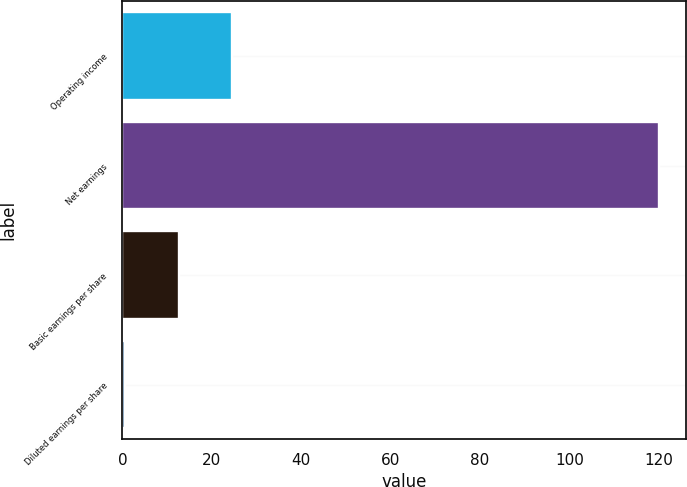Convert chart to OTSL. <chart><loc_0><loc_0><loc_500><loc_500><bar_chart><fcel>Operating income<fcel>Net earnings<fcel>Basic earnings per share<fcel>Diluted earnings per share<nl><fcel>24.54<fcel>120<fcel>12.61<fcel>0.68<nl></chart> 